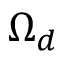Convert formula to latex. <formula><loc_0><loc_0><loc_500><loc_500>\Omega _ { d }</formula> 